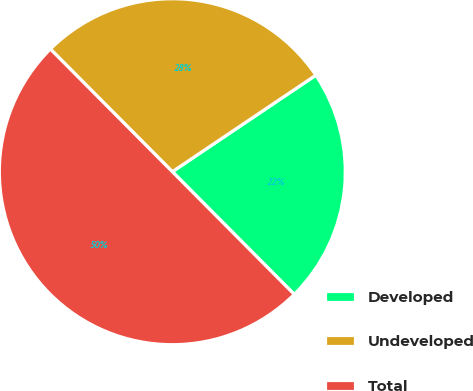<chart> <loc_0><loc_0><loc_500><loc_500><pie_chart><fcel>Developed<fcel>Undeveloped<fcel>Total<nl><fcel>21.97%<fcel>28.03%<fcel>50.0%<nl></chart> 